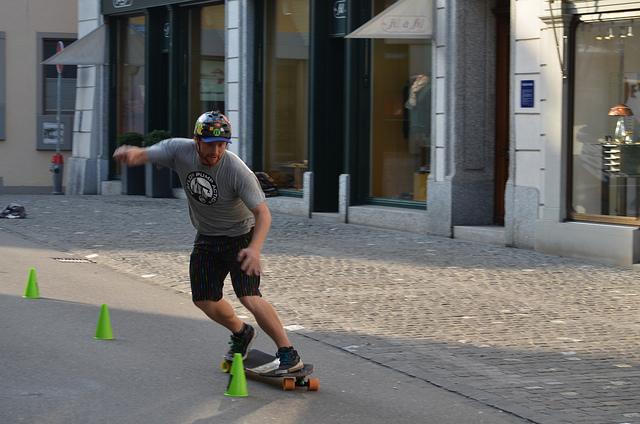Is the person on the skateboard wearing a helmet?
Give a very brief answer. Yes. Is the skateboarder male or female?
Keep it brief. Male. What color are the cones on the street?
Give a very brief answer. Green. 